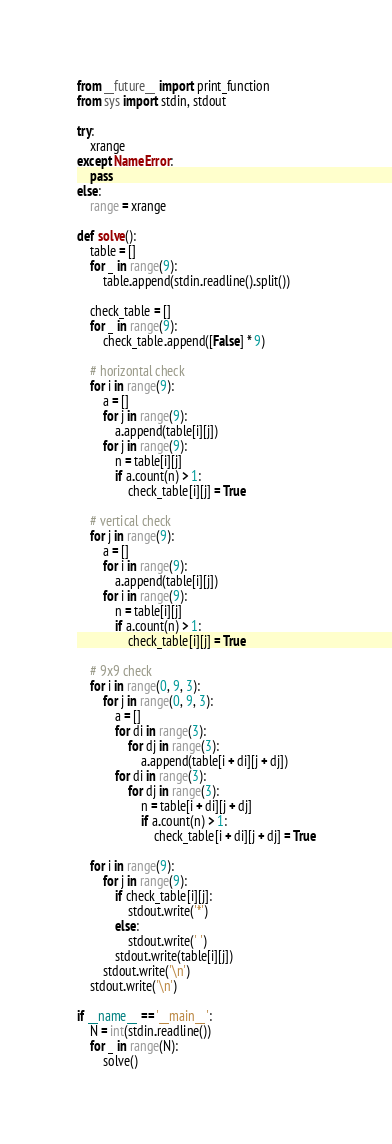Convert code to text. <code><loc_0><loc_0><loc_500><loc_500><_Python_>from __future__ import print_function
from sys import stdin, stdout

try:
    xrange
except NameError:
    pass
else:
    range = xrange

def solve():
    table = []
    for _ in range(9):
        table.append(stdin.readline().split())
    
    check_table = []
    for _ in range(9):
        check_table.append([False] * 9)
    
    # horizontal check
    for i in range(9):
        a = []
        for j in range(9):
            a.append(table[i][j])
        for j in range(9):
            n = table[i][j]
            if a.count(n) > 1:
                check_table[i][j] = True
    
    # vertical check
    for j in range(9):
        a = []
        for i in range(9):
            a.append(table[i][j])
        for i in range(9):
            n = table[i][j]
            if a.count(n) > 1:
                check_table[i][j] = True
    
    # 9x9 check
    for i in range(0, 9, 3):
        for j in range(0, 9, 3):
            a = []
            for di in range(3):
                for dj in range(3):
                    a.append(table[i + di][j + dj])
            for di in range(3):
                for dj in range(3):
                    n = table[i + di][j + dj]
                    if a.count(n) > 1:
                        check_table[i + di][j + dj] = True
    
    for i in range(9):
        for j in range(9):
            if check_table[i][j]:
                stdout.write('*')
            else:
                stdout.write(' ')
            stdout.write(table[i][j])
        stdout.write('\n')
    stdout.write('\n')

if __name__ == '__main__':
    N = int(stdin.readline())
    for _ in range(N):
        solve()</code> 